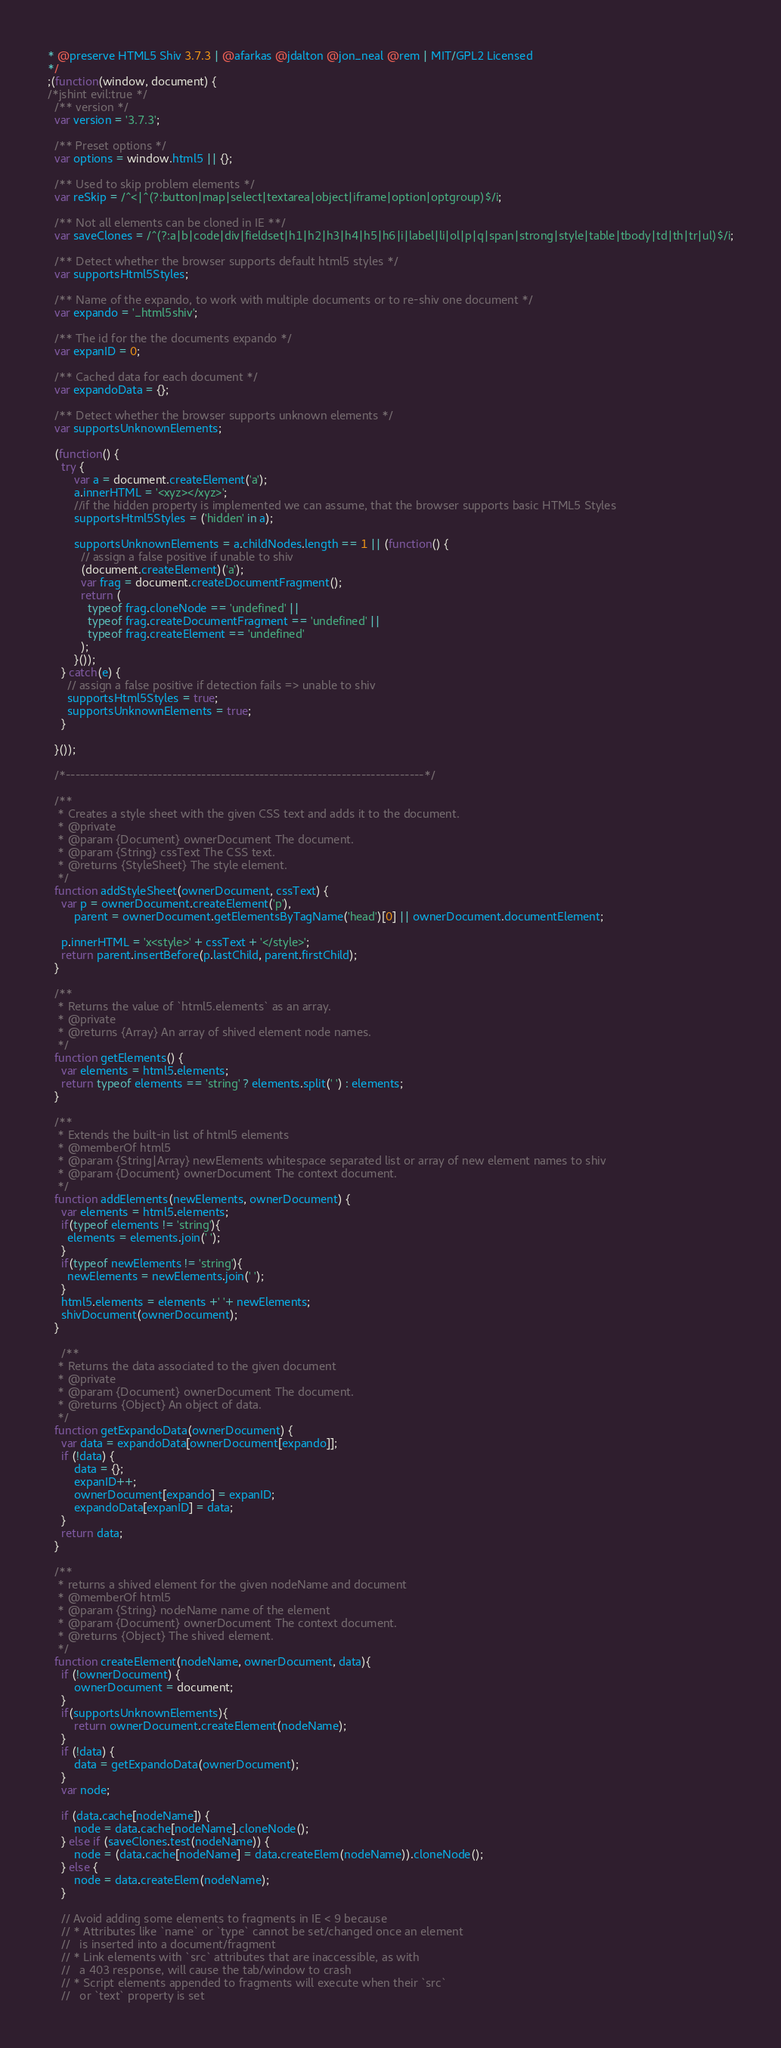Convert code to text. <code><loc_0><loc_0><loc_500><loc_500><_JavaScript_>* @preserve HTML5 Shiv 3.7.3 | @afarkas @jdalton @jon_neal @rem | MIT/GPL2 Licensed
*/
;(function(window, document) {
/*jshint evil:true */
  /** version */
  var version = '3.7.3';

  /** Preset options */
  var options = window.html5 || {};

  /** Used to skip problem elements */
  var reSkip = /^<|^(?:button|map|select|textarea|object|iframe|option|optgroup)$/i;

  /** Not all elements can be cloned in IE **/
  var saveClones = /^(?:a|b|code|div|fieldset|h1|h2|h3|h4|h5|h6|i|label|li|ol|p|q|span|strong|style|table|tbody|td|th|tr|ul)$/i;

  /** Detect whether the browser supports default html5 styles */
  var supportsHtml5Styles;

  /** Name of the expando, to work with multiple documents or to re-shiv one document */
  var expando = '_html5shiv';

  /** The id for the the documents expando */
  var expanID = 0;

  /** Cached data for each document */
  var expandoData = {};

  /** Detect whether the browser supports unknown elements */
  var supportsUnknownElements;

  (function() {
    try {
        var a = document.createElement('a');
        a.innerHTML = '<xyz></xyz>';
        //if the hidden property is implemented we can assume, that the browser supports basic HTML5 Styles
        supportsHtml5Styles = ('hidden' in a);

        supportsUnknownElements = a.childNodes.length == 1 || (function() {
          // assign a false positive if unable to shiv
          (document.createElement)('a');
          var frag = document.createDocumentFragment();
          return (
            typeof frag.cloneNode == 'undefined' ||
            typeof frag.createDocumentFragment == 'undefined' ||
            typeof frag.createElement == 'undefined'
          );
        }());
    } catch(e) {
      // assign a false positive if detection fails => unable to shiv
      supportsHtml5Styles = true;
      supportsUnknownElements = true;
    }

  }());

  /*--------------------------------------------------------------------------*/

  /**
   * Creates a style sheet with the given CSS text and adds it to the document.
   * @private
   * @param {Document} ownerDocument The document.
   * @param {String} cssText The CSS text.
   * @returns {StyleSheet} The style element.
   */
  function addStyleSheet(ownerDocument, cssText) {
    var p = ownerDocument.createElement('p'),
        parent = ownerDocument.getElementsByTagName('head')[0] || ownerDocument.documentElement;

    p.innerHTML = 'x<style>' + cssText + '</style>';
    return parent.insertBefore(p.lastChild, parent.firstChild);
  }

  /**
   * Returns the value of `html5.elements` as an array.
   * @private
   * @returns {Array} An array of shived element node names.
   */
  function getElements() {
    var elements = html5.elements;
    return typeof elements == 'string' ? elements.split(' ') : elements;
  }

  /**
   * Extends the built-in list of html5 elements
   * @memberOf html5
   * @param {String|Array} newElements whitespace separated list or array of new element names to shiv
   * @param {Document} ownerDocument The context document.
   */
  function addElements(newElements, ownerDocument) {
    var elements = html5.elements;
    if(typeof elements != 'string'){
      elements = elements.join(' ');
    }
    if(typeof newElements != 'string'){
      newElements = newElements.join(' ');
    }
    html5.elements = elements +' '+ newElements;
    shivDocument(ownerDocument);
  }

    /**
   * Returns the data associated to the given document
   * @private
   * @param {Document} ownerDocument The document.
   * @returns {Object} An object of data.
   */
  function getExpandoData(ownerDocument) {
    var data = expandoData[ownerDocument[expando]];
    if (!data) {
        data = {};
        expanID++;
        ownerDocument[expando] = expanID;
        expandoData[expanID] = data;
    }
    return data;
  }

  /**
   * returns a shived element for the given nodeName and document
   * @memberOf html5
   * @param {String} nodeName name of the element
   * @param {Document} ownerDocument The context document.
   * @returns {Object} The shived element.
   */
  function createElement(nodeName, ownerDocument, data){
    if (!ownerDocument) {
        ownerDocument = document;
    }
    if(supportsUnknownElements){
        return ownerDocument.createElement(nodeName);
    }
    if (!data) {
        data = getExpandoData(ownerDocument);
    }
    var node;

    if (data.cache[nodeName]) {
        node = data.cache[nodeName].cloneNode();
    } else if (saveClones.test(nodeName)) {
        node = (data.cache[nodeName] = data.createElem(nodeName)).cloneNode();
    } else {
        node = data.createElem(nodeName);
    }

    // Avoid adding some elements to fragments in IE < 9 because
    // * Attributes like `name` or `type` cannot be set/changed once an element
    //   is inserted into a document/fragment
    // * Link elements with `src` attributes that are inaccessible, as with
    //   a 403 response, will cause the tab/window to crash
    // * Script elements appended to fragments will execute when their `src`
    //   or `text` property is set</code> 